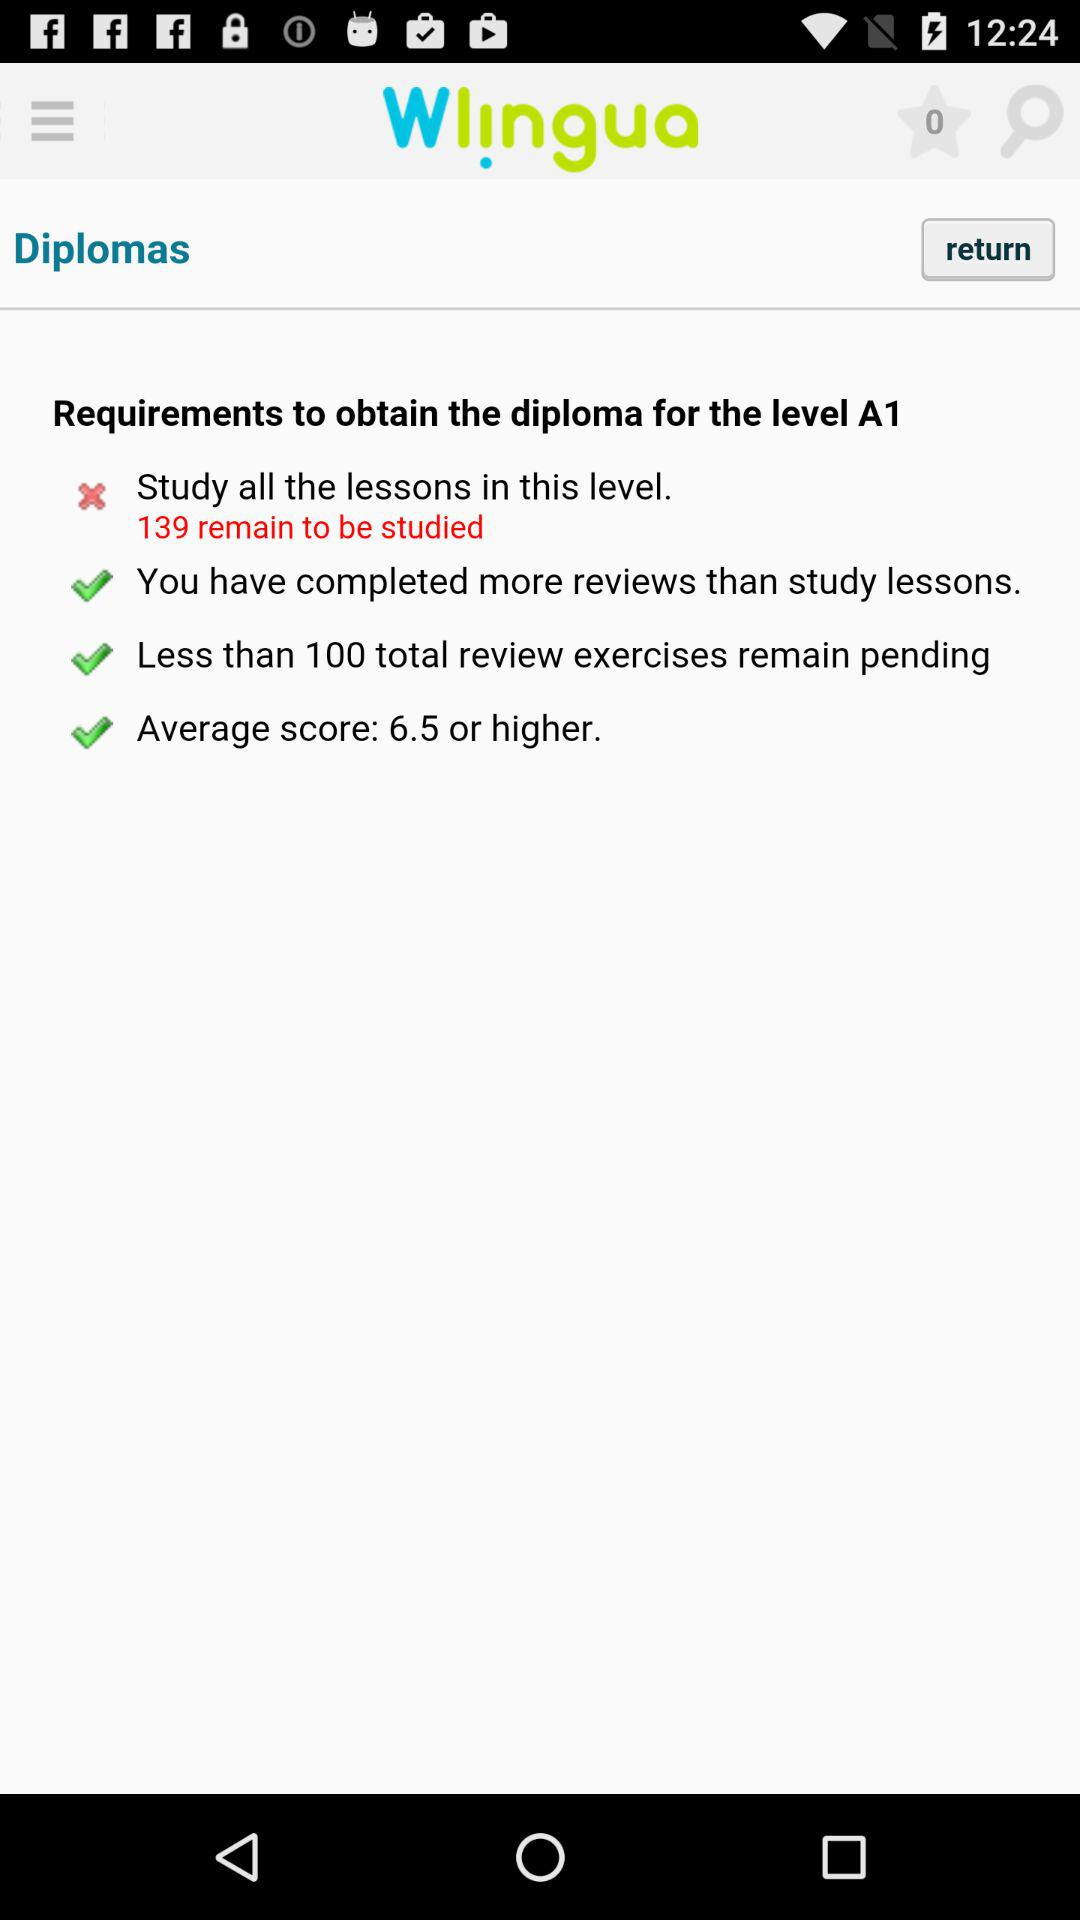How many total review exercises remain pending?
Answer the question using a single word or phrase. Less than 100 